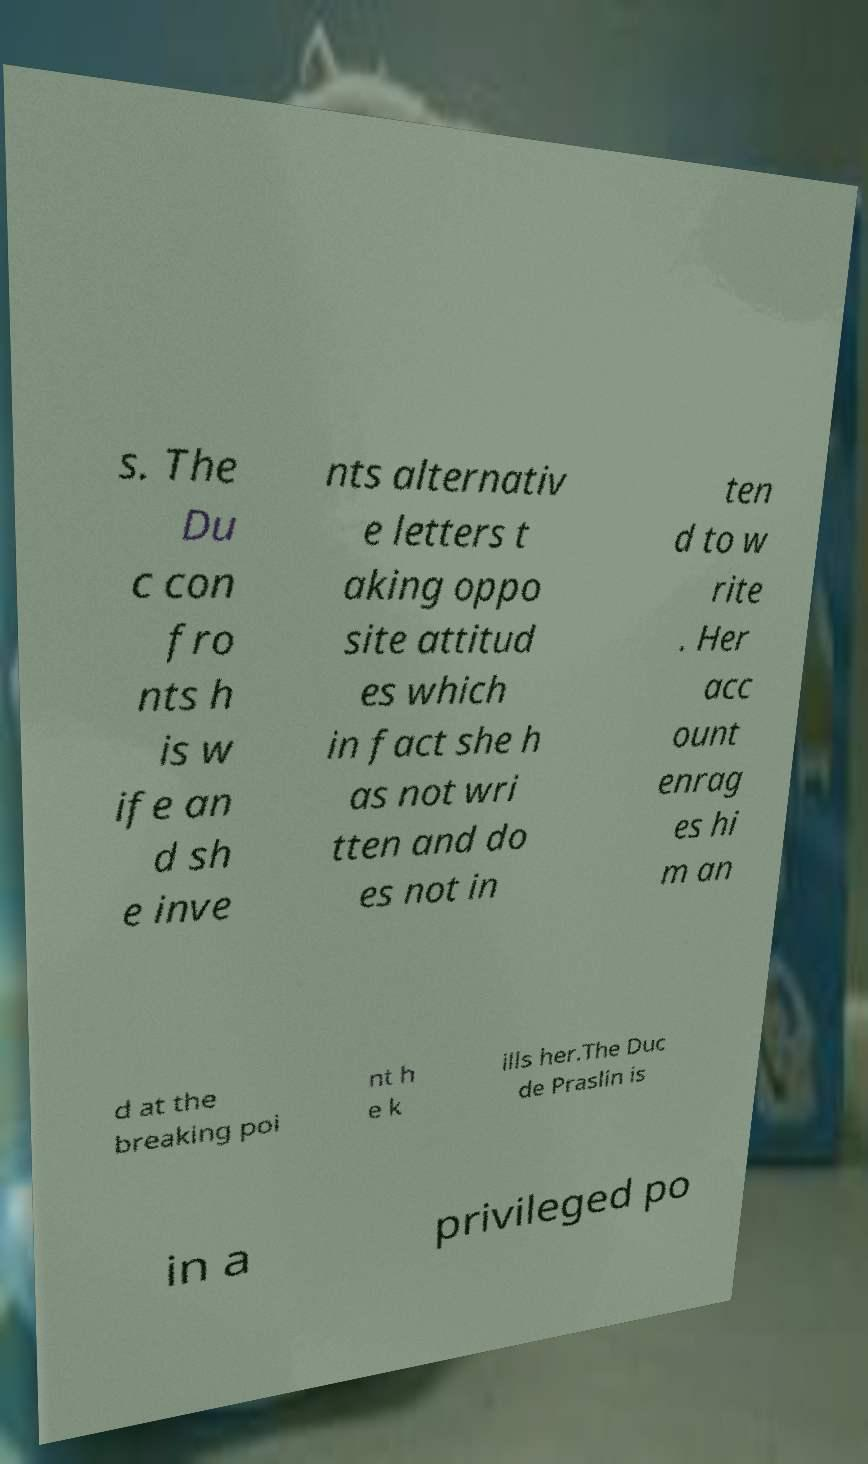Could you extract and type out the text from this image? s. The Du c con fro nts h is w ife an d sh e inve nts alternativ e letters t aking oppo site attitud es which in fact she h as not wri tten and do es not in ten d to w rite . Her acc ount enrag es hi m an d at the breaking poi nt h e k ills her.The Duc de Praslin is in a privileged po 